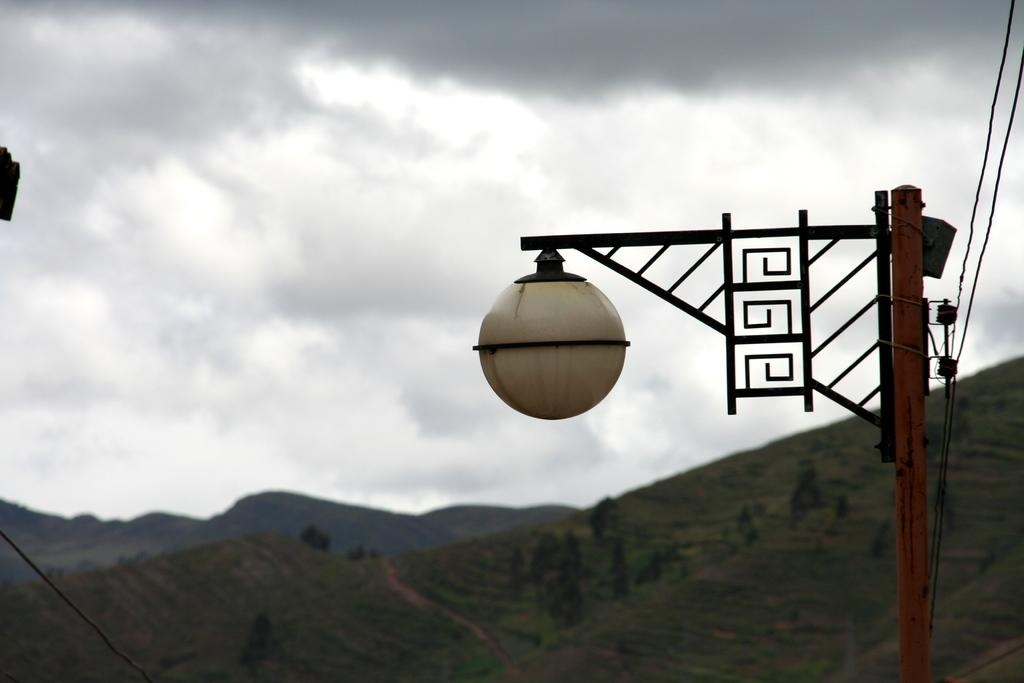What type of landscape can be seen in the image? There are hills in the image. What can be seen in the distance in the image? Light is visible in the image. What is visible in the upper part of the image? The sky is visible in the image. What is present in the sky in the image? Clouds are present in the image. What type of drum can be seen in the image? There is no drum present in the image. What is the value of the hills in the image? The value of the hills cannot be determined from the image alone, as value is a subjective concept. 